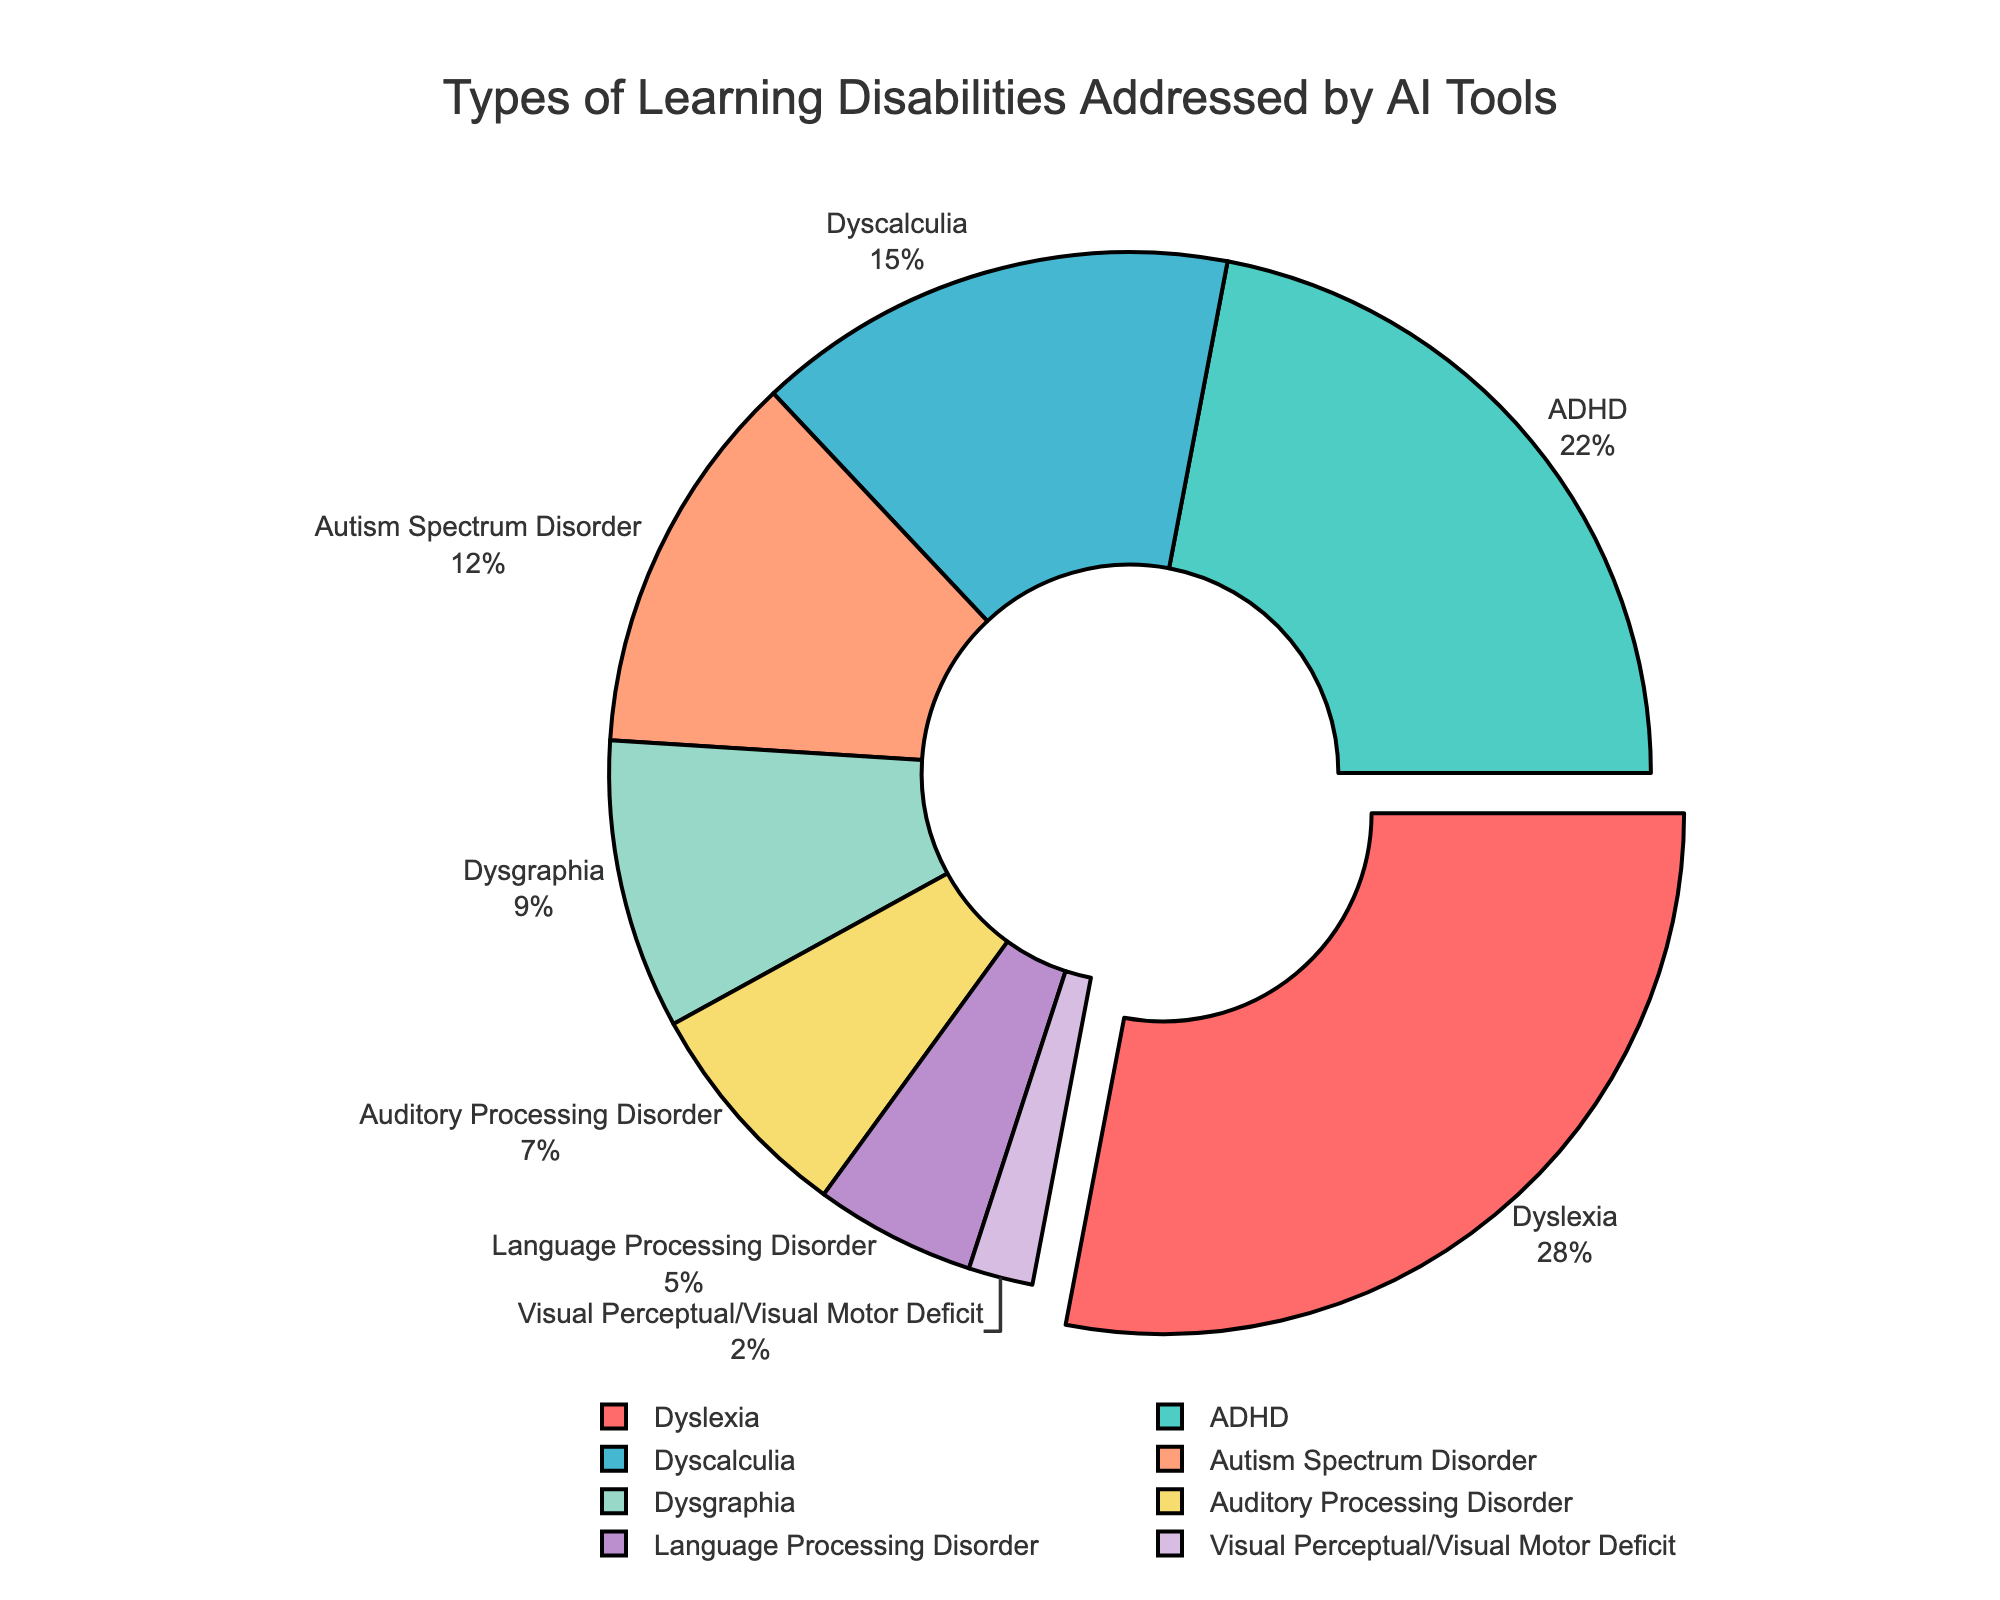What is the most addressed learning disability by AI tools? The figure shows a pie chart with various categories of learning disabilities. The largest segment, pulled out from the rest, represents Dyslexia. This suggests it is the most addressed.
Answer: Dyslexia Which learning disability occupies the smallest portion of the pie chart? By observing the pie chart, the smallest segment is the one labeled 'Visual Perceptual/Visual Motor Deficit'.
Answer: Visual Perceptual/Visual Motor Deficit How much more is the percentage of Dyslexia than the percentage of Auditory Processing Disorder? The pie chart shows Dyslexia at 28% and Auditory Processing Disorder at 7%. Subtracting the latter from the former gives: 28% - 7% = 21%.
Answer: 21% What is the combined percentage of Dyscalculia and Dysgraphia? By identifying these two segments in the pie chart, we see Dyscalculia at 15% and Dysgraphia at 9%. Adding these together: 15% + 9% = 24%.
Answer: 24% What are the visual attributes of the segment representing ADHD? The segment for ADHD can be identified by its position and color on the pie chart. It is placed next to the Dyslexia segment and is colored turquoise or blue-green.
Answer: Turquoise/blue-green Which two learning disabilities combined have a similar percentage to Dyslexia? Dyslexia is at 28%. Combining ADHD (22%) and Auditory Processing Disorder (7%) results in: 22% + 7% = 29%, which is close to Dyslexia's percentage.
Answer: ADHD and Auditory Processing Disorder How does the percentage for Language Processing Disorder compare to Autism Spectrum Disorder? The pie chart shows Autism Spectrum Disorder at 12% and Language Processing Disorder at 5%. The percentage for Autism Spectrum Disorder is more than double that of Language Processing Disorder.
Answer: Autism Spectrum Disorder has more than double the percentage What percentage of the total do the three smallest segments represent? The three smallest segments are Visual Perceptual/Visual Motor Deficit at 2%, Language Processing Disorder at 5%, and Auditory Processing Disorder at 7%. Adding these, we get: 2% + 5% + 7% = 14%.
Answer: 14% What is the average percentage of all the learning disabilities shown in the pie chart? Adding all percentages: 28% + 22% + 15% + 12% + 9% + 7% + 5% + 2% = 100%. There are 8 categories, thus the average is 100% / 8 = 12.5%.
Answer: 12.5% Which three learning disabilities together have a combined percentage greater than 50%? By examining the largest segments, combining Dyslexia (28%), ADHD (22%), and Dyscalculia (15%) yields: 28% + 22% + 15% = 65%, which is greater than 50%.
Answer: Dyslexia, ADHD, and Dyscalculia 